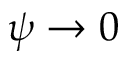<formula> <loc_0><loc_0><loc_500><loc_500>\psi \to 0</formula> 